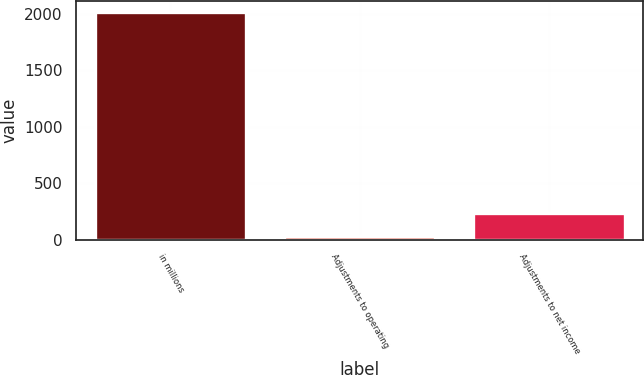Convert chart to OTSL. <chart><loc_0><loc_0><loc_500><loc_500><bar_chart><fcel>in millions<fcel>Adjustments to operating<fcel>Adjustments to net income<nl><fcel>2012<fcel>35.6<fcel>233.24<nl></chart> 